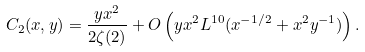Convert formula to latex. <formula><loc_0><loc_0><loc_500><loc_500>C _ { 2 } ( x , y ) = \frac { y x ^ { 2 } } { 2 \zeta ( 2 ) } + O \left ( y x ^ { 2 } L ^ { 1 0 } ( x ^ { - 1 / 2 } + x ^ { 2 } y ^ { - 1 } ) \right ) .</formula> 